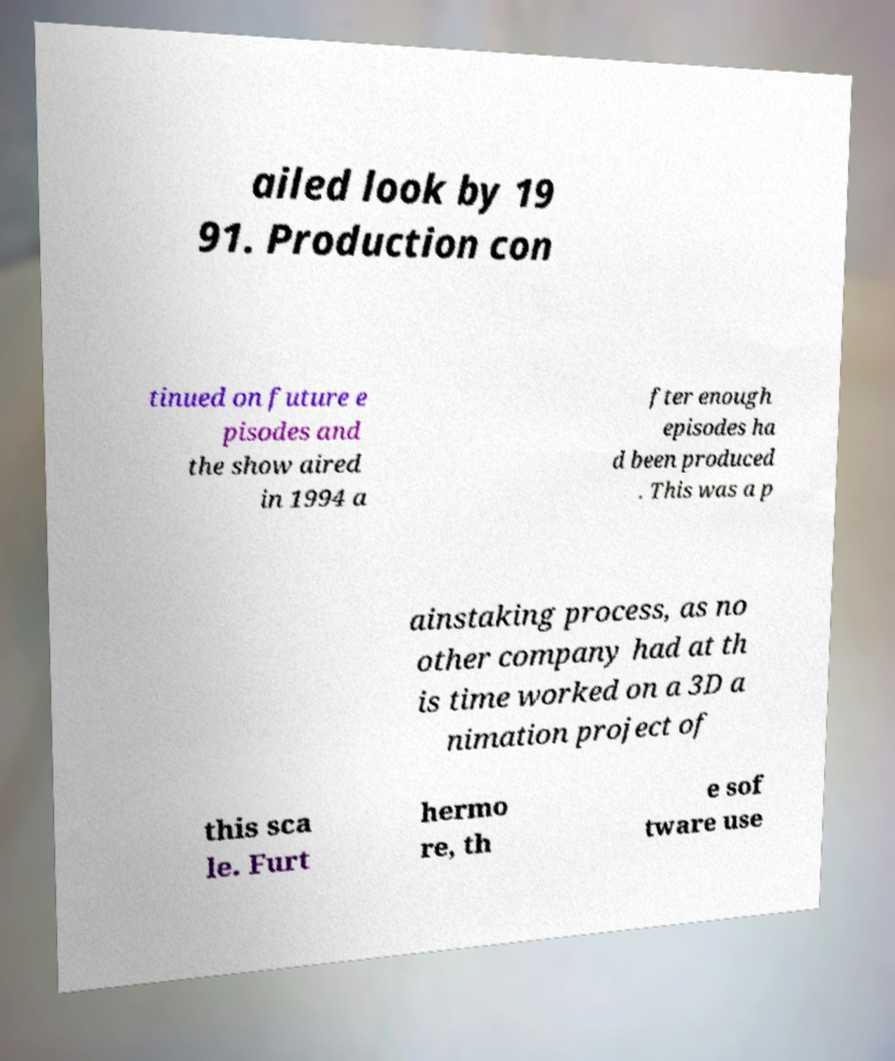Could you assist in decoding the text presented in this image and type it out clearly? ailed look by 19 91. Production con tinued on future e pisodes and the show aired in 1994 a fter enough episodes ha d been produced . This was a p ainstaking process, as no other company had at th is time worked on a 3D a nimation project of this sca le. Furt hermo re, th e sof tware use 